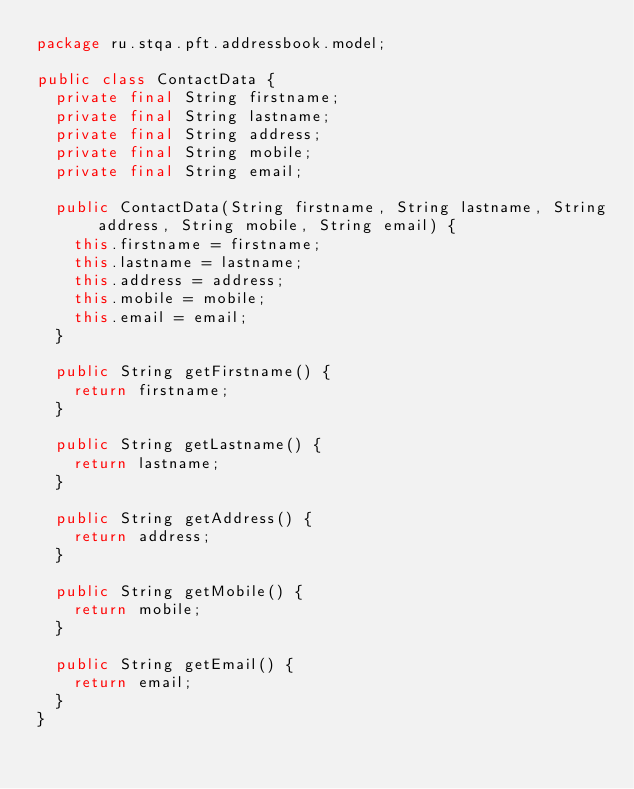Convert code to text. <code><loc_0><loc_0><loc_500><loc_500><_Java_>package ru.stqa.pft.addressbook.model;

public class ContactData {
  private final String firstname;
  private final String lastname;
  private final String address;
  private final String mobile;
  private final String email;

  public ContactData(String firstname, String lastname, String address, String mobile, String email) {
    this.firstname = firstname;
    this.lastname = lastname;
    this.address = address;
    this.mobile = mobile;
    this.email = email;
  }

  public String getFirstname() {
    return firstname;
  }

  public String getLastname() {
    return lastname;
  }

  public String getAddress() {
    return address;
  }

  public String getMobile() {
    return mobile;
  }

  public String getEmail() {
    return email;
  }
}
</code> 